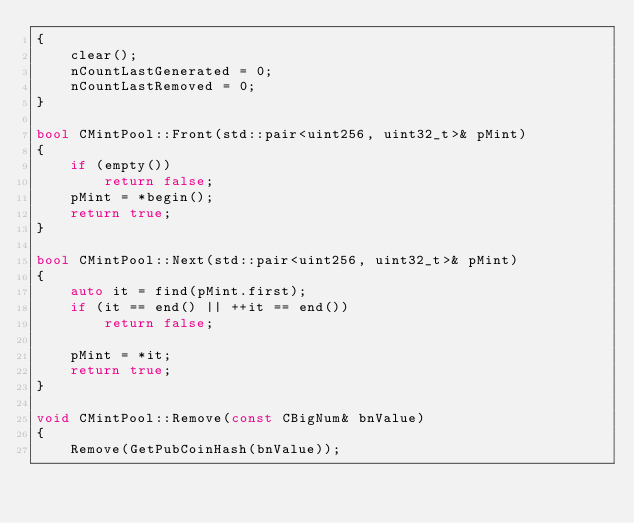<code> <loc_0><loc_0><loc_500><loc_500><_C++_>{
    clear();
    nCountLastGenerated = 0;
    nCountLastRemoved = 0;
}

bool CMintPool::Front(std::pair<uint256, uint32_t>& pMint)
{
    if (empty())
        return false;
    pMint = *begin();
    return true;
}

bool CMintPool::Next(std::pair<uint256, uint32_t>& pMint)
{
    auto it = find(pMint.first);
    if (it == end() || ++it == end())
        return false;

    pMint = *it;
    return true;
}

void CMintPool::Remove(const CBigNum& bnValue)
{
    Remove(GetPubCoinHash(bnValue));</code> 